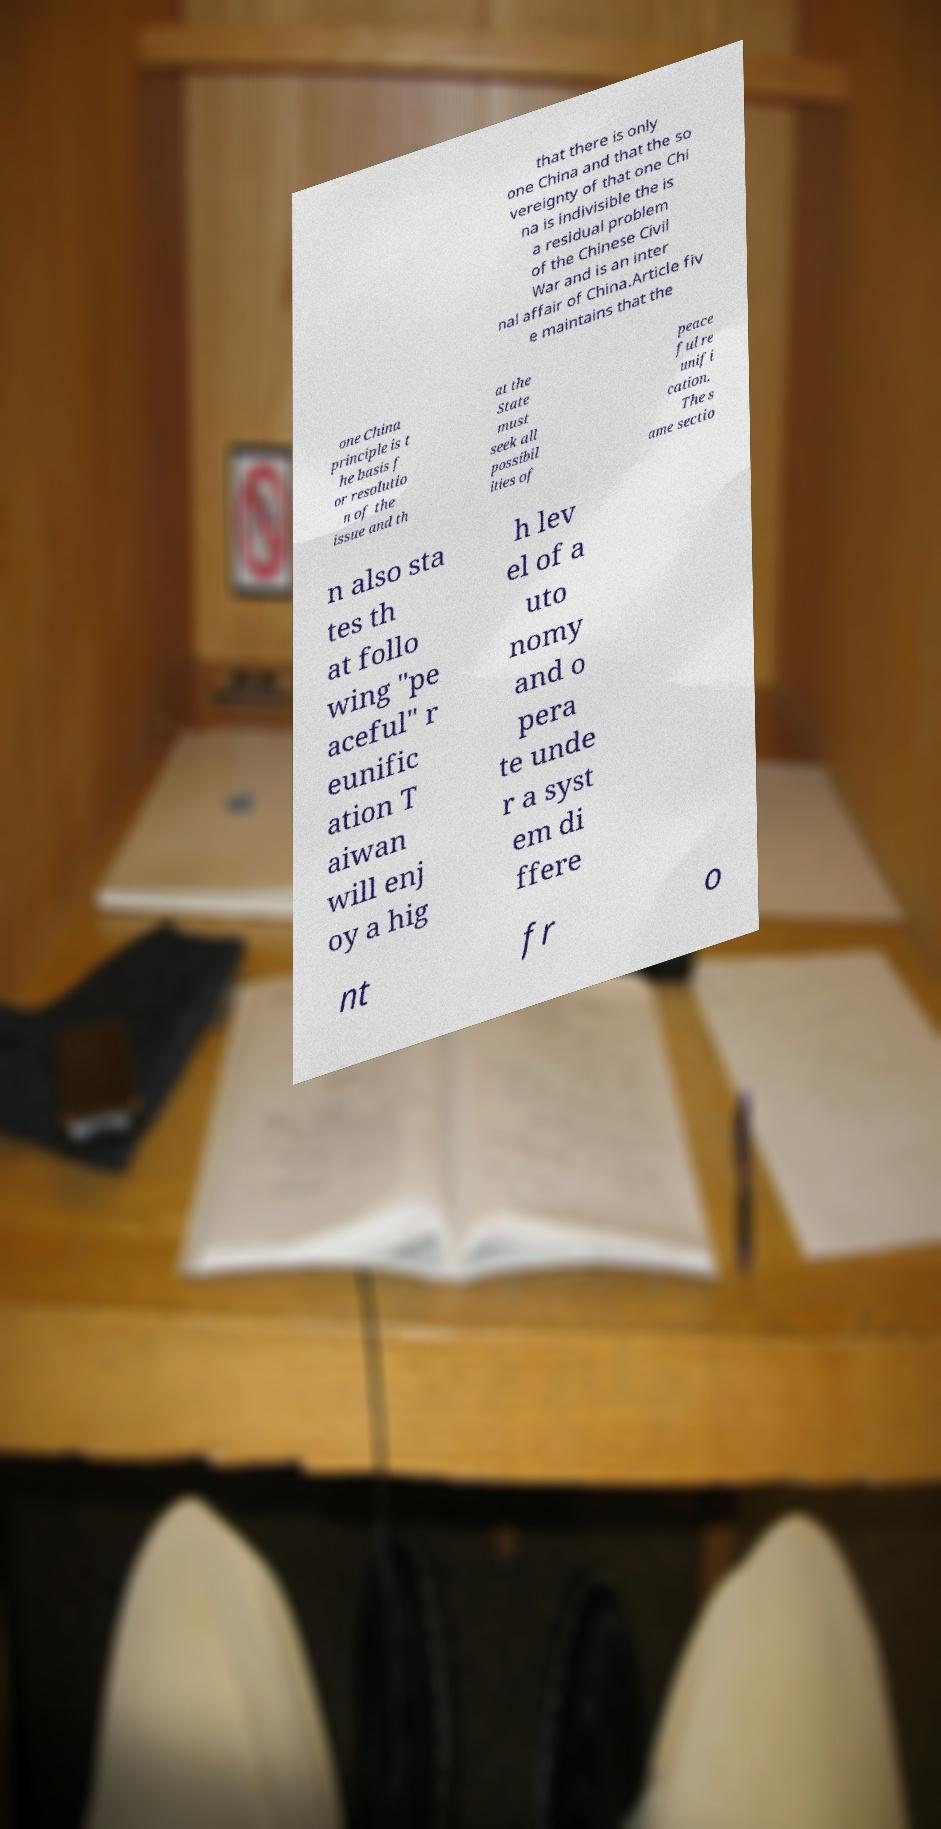Could you assist in decoding the text presented in this image and type it out clearly? that there is only one China and that the so vereignty of that one Chi na is indivisible the is a residual problem of the Chinese Civil War and is an inter nal affair of China.Article fiv e maintains that the one China principle is t he basis f or resolutio n of the issue and th at the State must seek all possibil ities of peace ful re unifi cation. The s ame sectio n also sta tes th at follo wing "pe aceful" r eunific ation T aiwan will enj oy a hig h lev el of a uto nomy and o pera te unde r a syst em di ffere nt fr o 